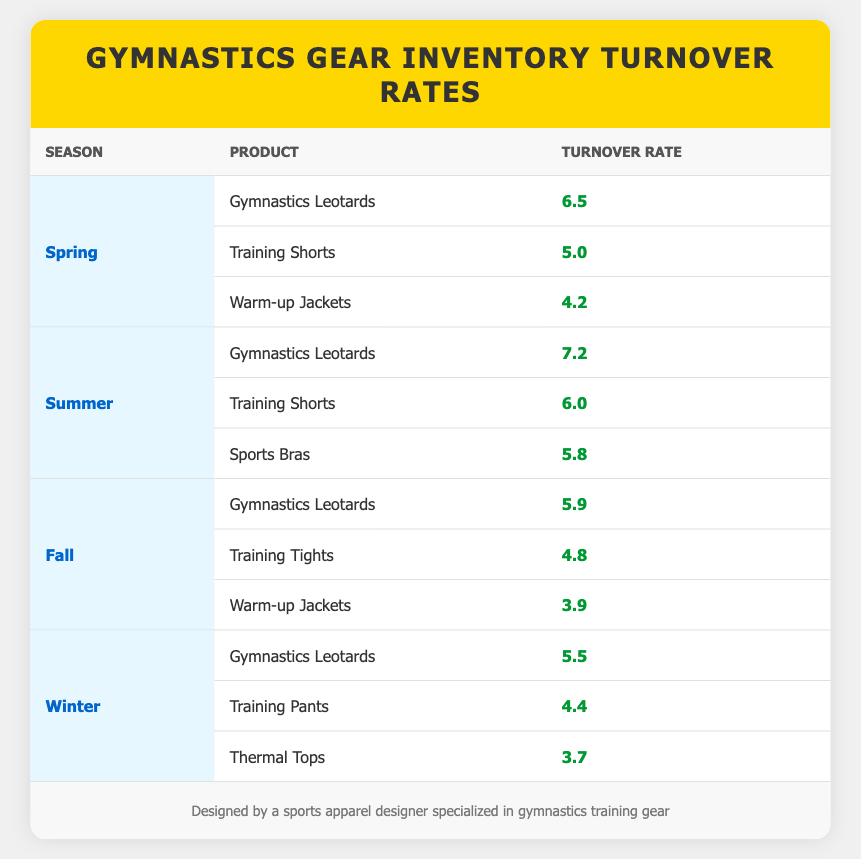What is the turnover rate for Gymnastics Leotards in Summer? The table lists the turnover rate for Gymnastics Leotards in the Summer season as 7.2.
Answer: 7.2 Which season has the highest turnover rate for Training Shorts? From the table, Summer has a turnover rate of 6.0 for Training Shorts, which is higher than Spring at 5.0 and Fall at 4.8. Therefore, Summer has the highest turnover rate for Training Shorts.
Answer: Summer What is the average turnover rate for Warm-up Jackets across all seasons? The turnover rates for Warm-up Jackets are 4.2 (Spring), 3.9 (Fall), and 0 (not listed for Summer and Winter). The average is calculated as (4.2 + 3.9) / 2 = 4.05 since there are only two data points available.
Answer: 4.05 Are there more products listed in Summer than in Winter? The Summer season lists three products (Gymnastics Leotards, Training Shorts, Sports Bras), and the Winter season also has three products (Gymnastics Leotards, Training Pants, Thermal Tops). Therefore, there are not more products in Summer than in Winter.
Answer: No What is the difference in turnover rates for Gymnastics Leotards between Spring and Fall? The turnover rate for Gymnastics Leotards in Spring is 6.5, and in Fall, it is 5.9. The difference is calculated as 6.5 - 5.9 = 0.6.
Answer: 0.6 Which product has the lowest turnover rate in the Winter season? In the Winter season, the turnover rates are 5.5 (Gymnastics Leotards), 4.4 (Training Pants), and 3.7 (Thermal Tops). The lowest turnover rate is 3.7 for Thermal Tops.
Answer: Thermal Tops Is it true that Training Pants have a higher turnover rate than Warm-up Jackets in Winter? In Winter, Training Pants have a turnover rate of 4.4, while Warm-up Jackets are not listed. Therefore, since Warm-up Jackets have a lower available turnover rate (not applicable), it is true that Training Pants have a higher turnover rate.
Answer: Yes What is the turnover rate of the least popular product across all seasons? Analyzing the table, the lowest turnover rates are 3.7 (Thermal Tops in Winter) and 3.9 (Warm-up Jackets in Fall). The lowest is therefore 3.7.
Answer: 3.7 Which season shows the greatest turnover rate for all products combined? The total turnover rates per season are calculated as follows: Spring = 6.5 + 5.0 + 4.2 = 15.7; Summer = 7.2 + 6.0 + 5.8 = 19.0; Fall = 5.9 + 4.8 + 3.9 = 14.6; Winter = 5.5 + 4.4 + 3.7 = 13.6. Thus, the greatest turnover rate is in Summer, with a total of 19.0.
Answer: Summer 